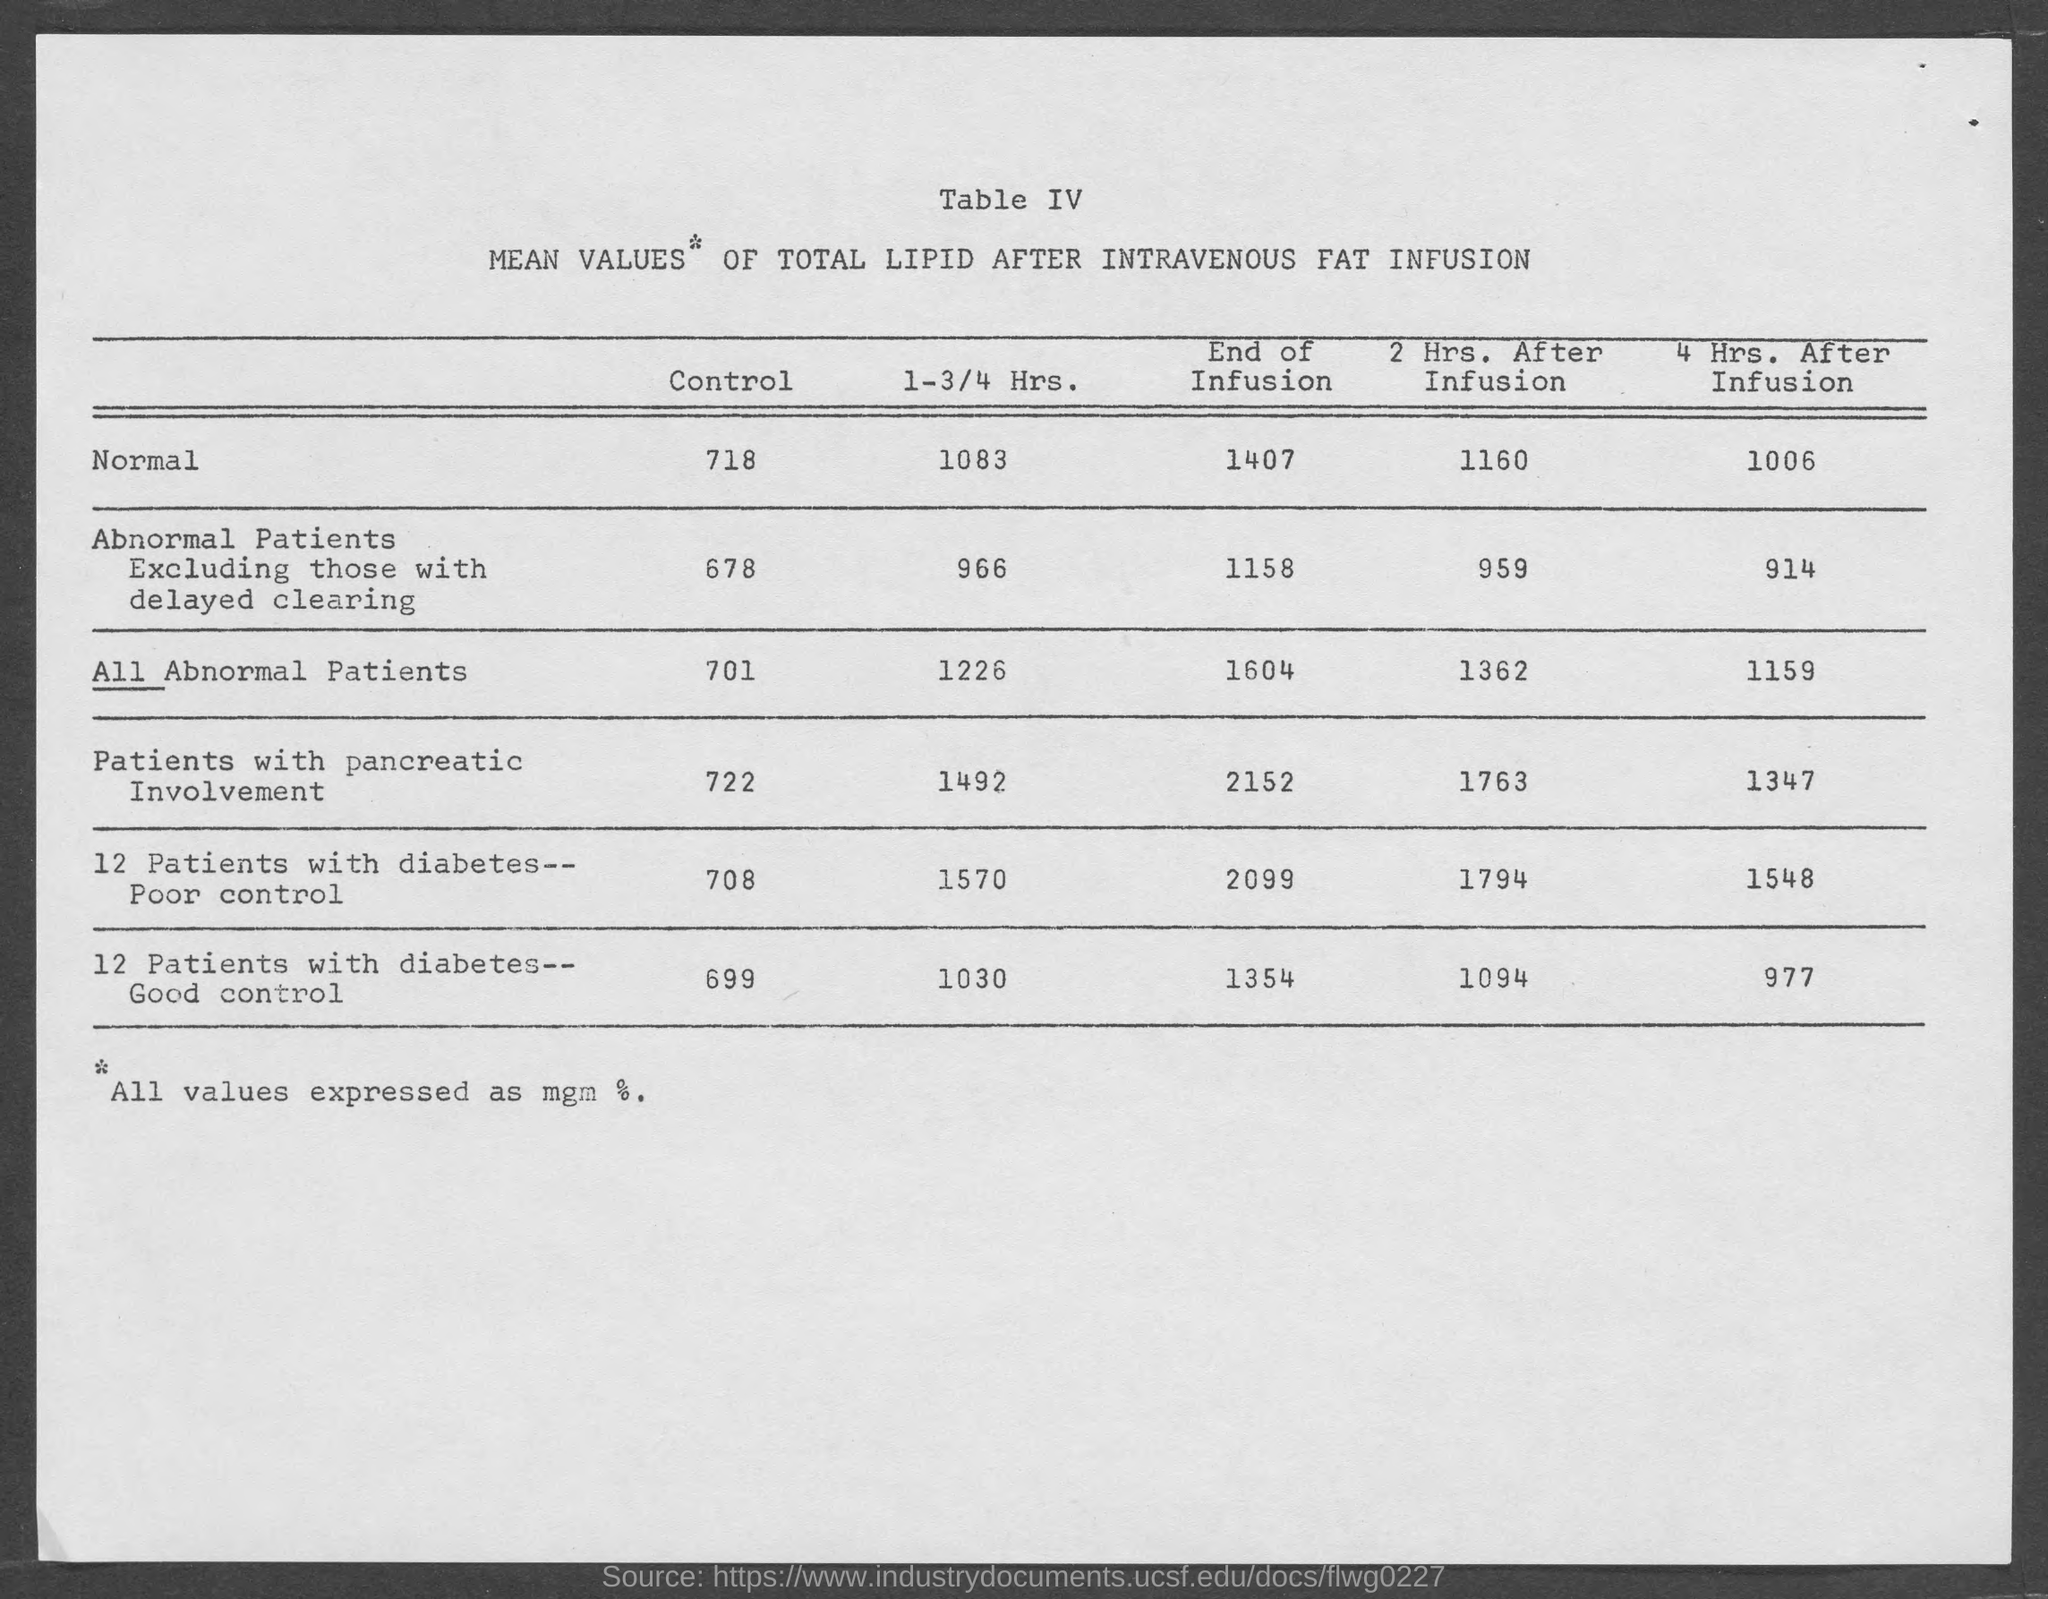What is the table number?
Give a very brief answer. Table iv. What is the normal control?
Give a very brief answer. 718. 